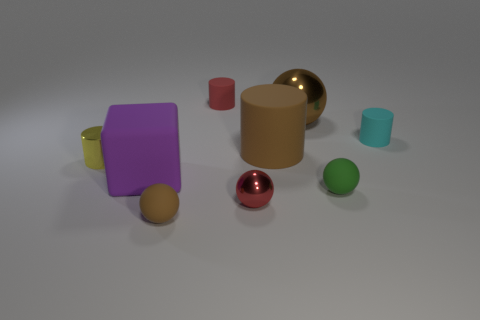What is the shape of the large thing on the left side of the metal sphere that is in front of the small cylinder that is to the right of the large brown metallic thing?
Your answer should be very brief. Cube. Does the big rubber object that is right of the tiny red shiny object have the same color as the metal sphere that is behind the small green thing?
Offer a very short reply. Yes. How many small metallic cylinders are there?
Keep it short and to the point. 1. There is a tiny brown object; are there any rubber balls right of it?
Offer a terse response. Yes. Do the tiny thing behind the cyan cylinder and the small red object that is in front of the green sphere have the same material?
Provide a short and direct response. No. Is the number of brown cylinders that are behind the large brown cylinder less than the number of brown cylinders?
Give a very brief answer. Yes. What is the color of the shiny ball behind the cyan matte object?
Offer a terse response. Brown. There is a object behind the brown ball that is on the right side of the red matte object; what is it made of?
Give a very brief answer. Rubber. Are there any blue shiny things that have the same size as the cyan matte object?
Your answer should be compact. No. What number of things are balls left of the red metallic sphere or small shiny things that are in front of the big matte block?
Provide a succinct answer. 2. 